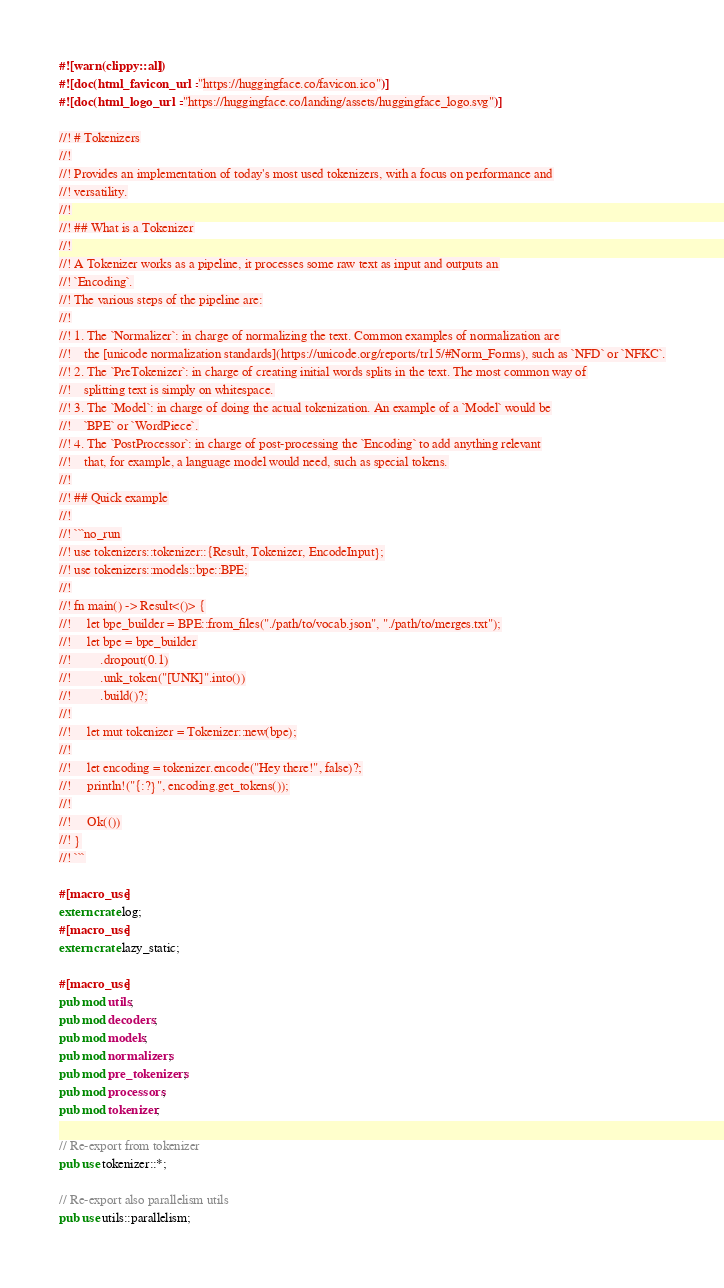<code> <loc_0><loc_0><loc_500><loc_500><_Rust_>#![warn(clippy::all)]
#![doc(html_favicon_url = "https://huggingface.co/favicon.ico")]
#![doc(html_logo_url = "https://huggingface.co/landing/assets/huggingface_logo.svg")]

//! # Tokenizers
//!
//! Provides an implementation of today's most used tokenizers, with a focus on performance and
//! versatility.
//!
//! ## What is a Tokenizer
//!
//! A Tokenizer works as a pipeline, it processes some raw text as input and outputs an
//! `Encoding`.
//! The various steps of the pipeline are:
//!
//! 1. The `Normalizer`: in charge of normalizing the text. Common examples of normalization are
//!    the [unicode normalization standards](https://unicode.org/reports/tr15/#Norm_Forms), such as `NFD` or `NFKC`.
//! 2. The `PreTokenizer`: in charge of creating initial words splits in the text. The most common way of
//!    splitting text is simply on whitespace.
//! 3. The `Model`: in charge of doing the actual tokenization. An example of a `Model` would be
//!    `BPE` or `WordPiece`.
//! 4. The `PostProcessor`: in charge of post-processing the `Encoding` to add anything relevant
//!    that, for example, a language model would need, such as special tokens.
//!
//! ## Quick example
//!
//! ```no_run
//! use tokenizers::tokenizer::{Result, Tokenizer, EncodeInput};
//! use tokenizers::models::bpe::BPE;
//!
//! fn main() -> Result<()> {
//!     let bpe_builder = BPE::from_files("./path/to/vocab.json", "./path/to/merges.txt");
//!     let bpe = bpe_builder
//!         .dropout(0.1)
//!         .unk_token("[UNK]".into())
//!         .build()?;
//!
//!     let mut tokenizer = Tokenizer::new(bpe);
//!
//!     let encoding = tokenizer.encode("Hey there!", false)?;
//!     println!("{:?}", encoding.get_tokens());
//!
//!     Ok(())
//! }
//! ```

#[macro_use]
extern crate log;
#[macro_use]
extern crate lazy_static;

#[macro_use]
pub mod utils;
pub mod decoders;
pub mod models;
pub mod normalizers;
pub mod pre_tokenizers;
pub mod processors;
pub mod tokenizer;

// Re-export from tokenizer
pub use tokenizer::*;

// Re-export also parallelism utils
pub use utils::parallelism;
</code> 